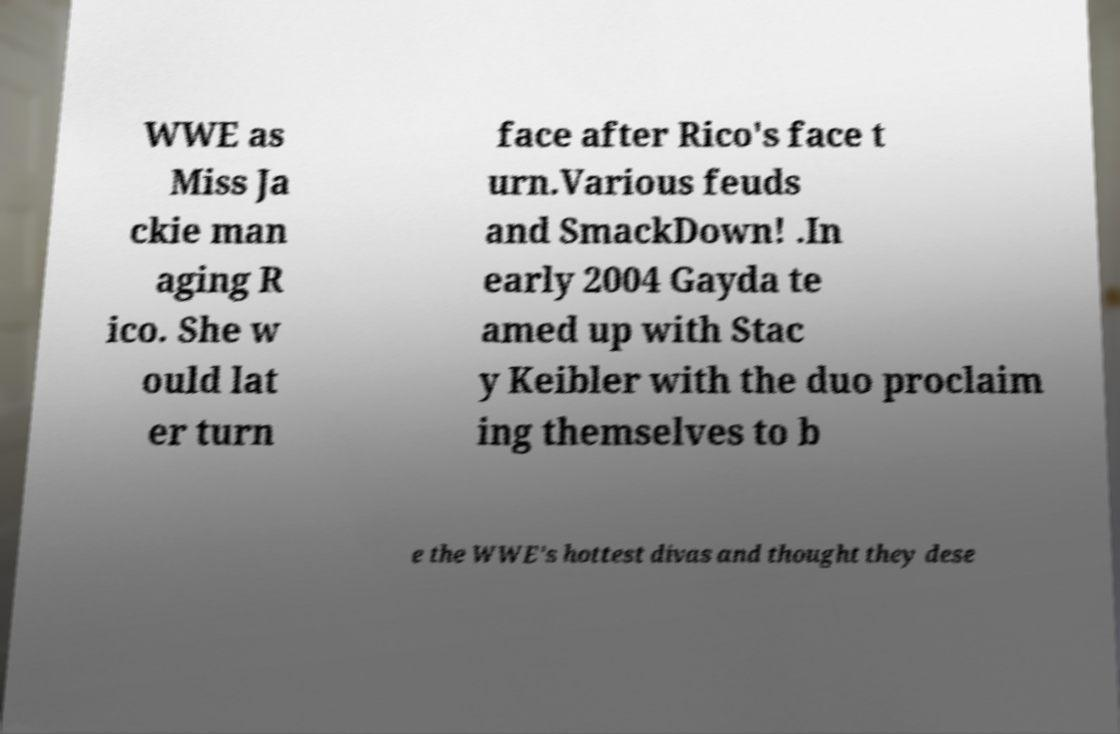I need the written content from this picture converted into text. Can you do that? WWE as Miss Ja ckie man aging R ico. She w ould lat er turn face after Rico's face t urn.Various feuds and SmackDown! .In early 2004 Gayda te amed up with Stac y Keibler with the duo proclaim ing themselves to b e the WWE's hottest divas and thought they dese 